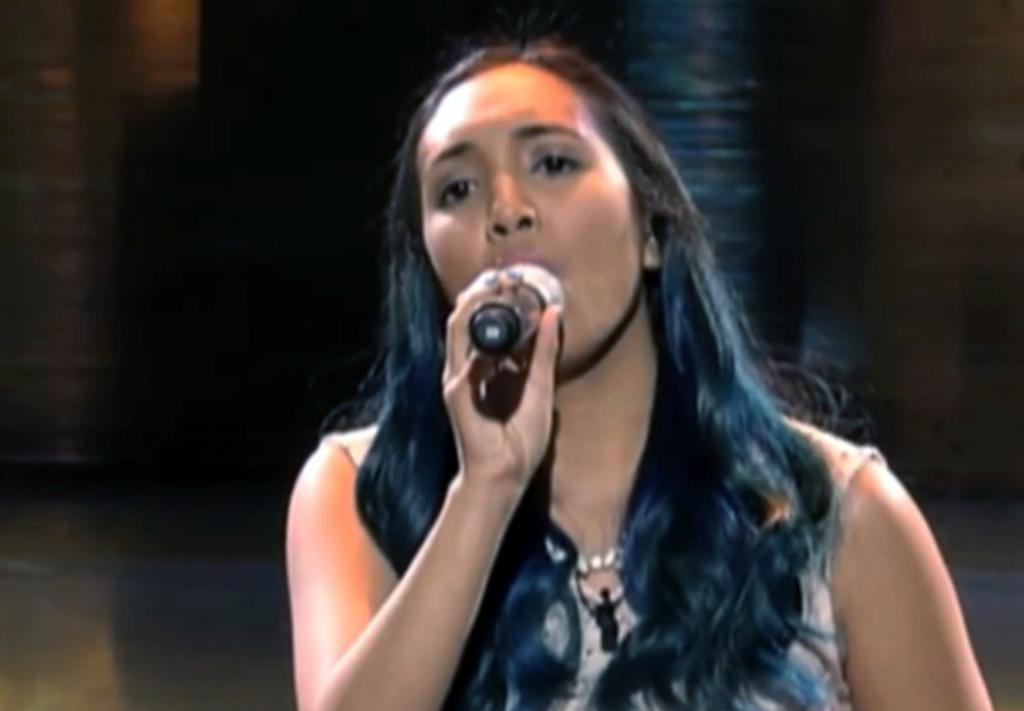Could you give a brief overview of what you see in this image? The woman holding a mike in her right hand is singing. 